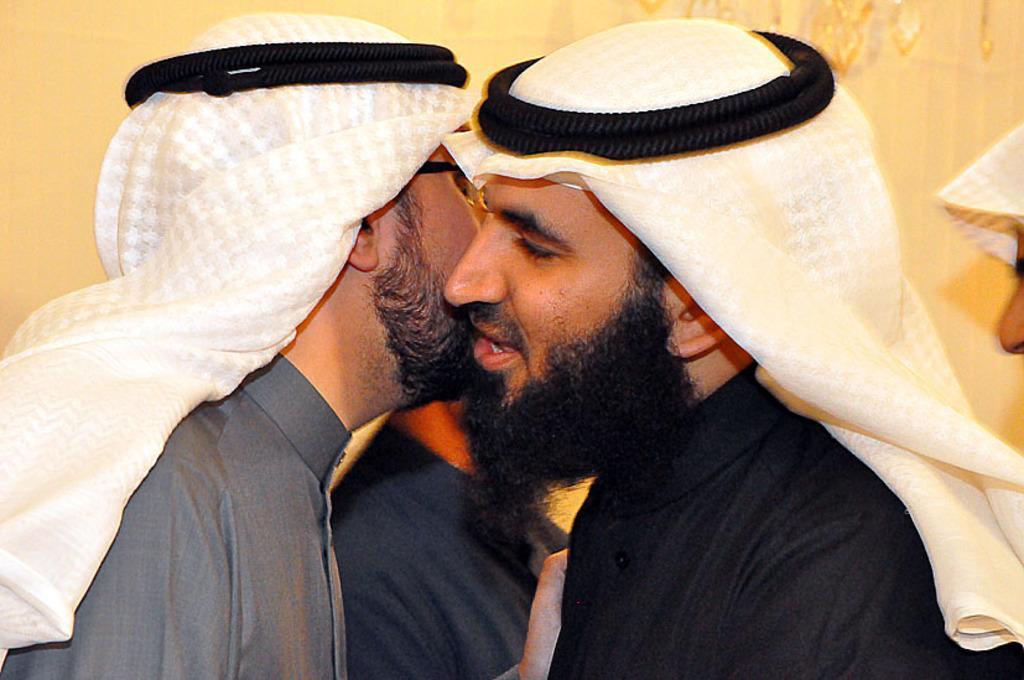How would you summarize this image in a sentence or two? In this image in the foreground there are two persons, who are talking and they are wearing arabic headscarves. In the background there are some people and wall and some objects, on the right side. 